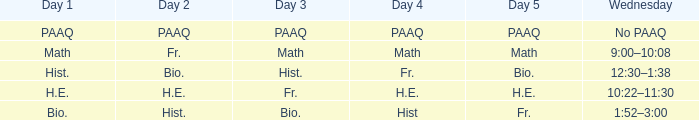What is the day 1 when day 5 is math? Math. 